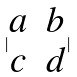<formula> <loc_0><loc_0><loc_500><loc_500>| \begin{matrix} a & b \\ c & d \end{matrix} |</formula> 